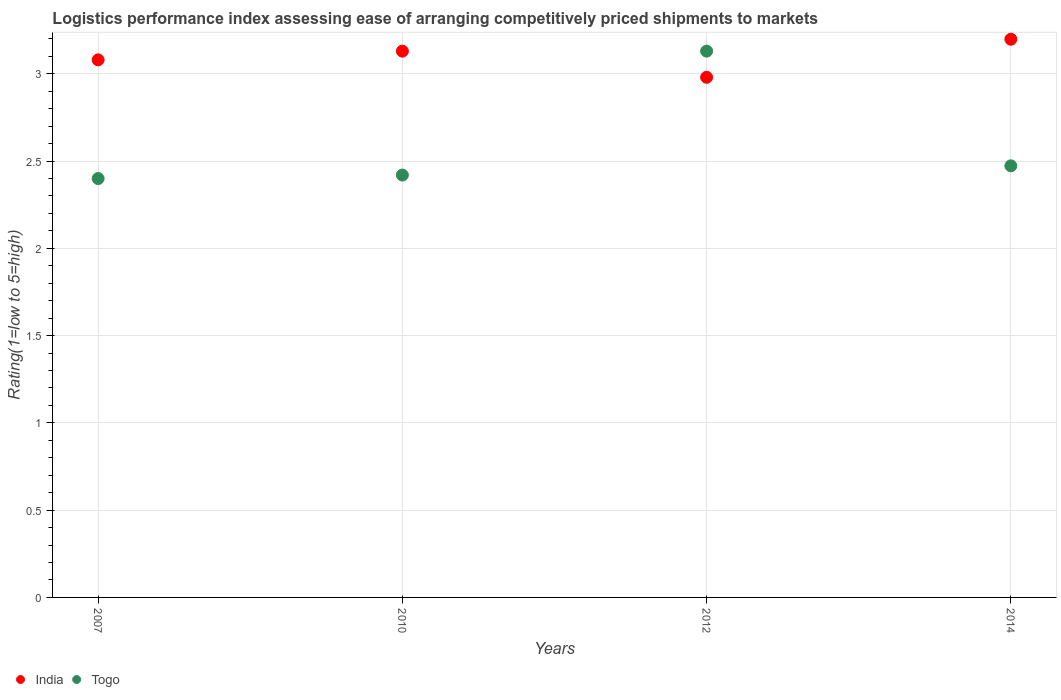Is the number of dotlines equal to the number of legend labels?
Provide a short and direct response. Yes. What is the Logistic performance index in Togo in 2012?
Offer a terse response. 3.13. Across all years, what is the maximum Logistic performance index in Togo?
Make the answer very short. 3.13. What is the total Logistic performance index in India in the graph?
Give a very brief answer. 12.39. What is the difference between the Logistic performance index in India in 2007 and that in 2014?
Your answer should be compact. -0.12. What is the difference between the Logistic performance index in Togo in 2014 and the Logistic performance index in India in 2012?
Keep it short and to the point. -0.51. What is the average Logistic performance index in India per year?
Offer a very short reply. 3.1. In the year 2010, what is the difference between the Logistic performance index in India and Logistic performance index in Togo?
Your response must be concise. 0.71. In how many years, is the Logistic performance index in India greater than 0.5?
Keep it short and to the point. 4. What is the ratio of the Logistic performance index in India in 2012 to that in 2014?
Your answer should be very brief. 0.93. Is the Logistic performance index in India in 2010 less than that in 2014?
Ensure brevity in your answer.  Yes. What is the difference between the highest and the second highest Logistic performance index in India?
Ensure brevity in your answer.  0.07. What is the difference between the highest and the lowest Logistic performance index in Togo?
Offer a terse response. 0.73. In how many years, is the Logistic performance index in Togo greater than the average Logistic performance index in Togo taken over all years?
Give a very brief answer. 1. Is the sum of the Logistic performance index in Togo in 2007 and 2012 greater than the maximum Logistic performance index in India across all years?
Make the answer very short. Yes. Is the Logistic performance index in India strictly greater than the Logistic performance index in Togo over the years?
Your response must be concise. No. Is the Logistic performance index in India strictly less than the Logistic performance index in Togo over the years?
Ensure brevity in your answer.  No. How many dotlines are there?
Give a very brief answer. 2. How many years are there in the graph?
Ensure brevity in your answer.  4. Does the graph contain any zero values?
Offer a very short reply. No. Where does the legend appear in the graph?
Give a very brief answer. Bottom left. How many legend labels are there?
Offer a very short reply. 2. What is the title of the graph?
Your response must be concise. Logistics performance index assessing ease of arranging competitively priced shipments to markets. What is the label or title of the Y-axis?
Ensure brevity in your answer.  Rating(1=low to 5=high). What is the Rating(1=low to 5=high) in India in 2007?
Offer a very short reply. 3.08. What is the Rating(1=low to 5=high) in India in 2010?
Your response must be concise. 3.13. What is the Rating(1=low to 5=high) in Togo in 2010?
Your answer should be compact. 2.42. What is the Rating(1=low to 5=high) of India in 2012?
Your response must be concise. 2.98. What is the Rating(1=low to 5=high) in Togo in 2012?
Ensure brevity in your answer.  3.13. What is the Rating(1=low to 5=high) of India in 2014?
Make the answer very short. 3.2. What is the Rating(1=low to 5=high) of Togo in 2014?
Your response must be concise. 2.47. Across all years, what is the maximum Rating(1=low to 5=high) of India?
Offer a very short reply. 3.2. Across all years, what is the maximum Rating(1=low to 5=high) of Togo?
Provide a succinct answer. 3.13. Across all years, what is the minimum Rating(1=low to 5=high) of India?
Offer a terse response. 2.98. Across all years, what is the minimum Rating(1=low to 5=high) of Togo?
Provide a short and direct response. 2.4. What is the total Rating(1=low to 5=high) of India in the graph?
Your response must be concise. 12.39. What is the total Rating(1=low to 5=high) of Togo in the graph?
Your response must be concise. 10.42. What is the difference between the Rating(1=low to 5=high) in India in 2007 and that in 2010?
Your response must be concise. -0.05. What is the difference between the Rating(1=low to 5=high) in Togo in 2007 and that in 2010?
Your response must be concise. -0.02. What is the difference between the Rating(1=low to 5=high) of Togo in 2007 and that in 2012?
Provide a succinct answer. -0.73. What is the difference between the Rating(1=low to 5=high) of India in 2007 and that in 2014?
Keep it short and to the point. -0.12. What is the difference between the Rating(1=low to 5=high) in Togo in 2007 and that in 2014?
Provide a short and direct response. -0.07. What is the difference between the Rating(1=low to 5=high) of India in 2010 and that in 2012?
Keep it short and to the point. 0.15. What is the difference between the Rating(1=low to 5=high) of Togo in 2010 and that in 2012?
Your answer should be compact. -0.71. What is the difference between the Rating(1=low to 5=high) of India in 2010 and that in 2014?
Provide a succinct answer. -0.07. What is the difference between the Rating(1=low to 5=high) in Togo in 2010 and that in 2014?
Offer a very short reply. -0.05. What is the difference between the Rating(1=low to 5=high) in India in 2012 and that in 2014?
Provide a short and direct response. -0.22. What is the difference between the Rating(1=low to 5=high) of Togo in 2012 and that in 2014?
Provide a succinct answer. 0.66. What is the difference between the Rating(1=low to 5=high) in India in 2007 and the Rating(1=low to 5=high) in Togo in 2010?
Ensure brevity in your answer.  0.66. What is the difference between the Rating(1=low to 5=high) of India in 2007 and the Rating(1=low to 5=high) of Togo in 2014?
Provide a succinct answer. 0.61. What is the difference between the Rating(1=low to 5=high) in India in 2010 and the Rating(1=low to 5=high) in Togo in 2014?
Provide a succinct answer. 0.66. What is the difference between the Rating(1=low to 5=high) in India in 2012 and the Rating(1=low to 5=high) in Togo in 2014?
Your answer should be very brief. 0.51. What is the average Rating(1=low to 5=high) of India per year?
Offer a terse response. 3.1. What is the average Rating(1=low to 5=high) in Togo per year?
Offer a terse response. 2.61. In the year 2007, what is the difference between the Rating(1=low to 5=high) of India and Rating(1=low to 5=high) of Togo?
Your answer should be very brief. 0.68. In the year 2010, what is the difference between the Rating(1=low to 5=high) of India and Rating(1=low to 5=high) of Togo?
Provide a short and direct response. 0.71. In the year 2012, what is the difference between the Rating(1=low to 5=high) in India and Rating(1=low to 5=high) in Togo?
Your answer should be compact. -0.15. In the year 2014, what is the difference between the Rating(1=low to 5=high) in India and Rating(1=low to 5=high) in Togo?
Give a very brief answer. 0.73. What is the ratio of the Rating(1=low to 5=high) in Togo in 2007 to that in 2010?
Your response must be concise. 0.99. What is the ratio of the Rating(1=low to 5=high) of India in 2007 to that in 2012?
Ensure brevity in your answer.  1.03. What is the ratio of the Rating(1=low to 5=high) in Togo in 2007 to that in 2012?
Give a very brief answer. 0.77. What is the ratio of the Rating(1=low to 5=high) of India in 2007 to that in 2014?
Offer a terse response. 0.96. What is the ratio of the Rating(1=low to 5=high) of Togo in 2007 to that in 2014?
Offer a terse response. 0.97. What is the ratio of the Rating(1=low to 5=high) of India in 2010 to that in 2012?
Give a very brief answer. 1.05. What is the ratio of the Rating(1=low to 5=high) of Togo in 2010 to that in 2012?
Ensure brevity in your answer.  0.77. What is the ratio of the Rating(1=low to 5=high) in India in 2010 to that in 2014?
Give a very brief answer. 0.98. What is the ratio of the Rating(1=low to 5=high) in Togo in 2010 to that in 2014?
Keep it short and to the point. 0.98. What is the ratio of the Rating(1=low to 5=high) in India in 2012 to that in 2014?
Your answer should be compact. 0.93. What is the ratio of the Rating(1=low to 5=high) of Togo in 2012 to that in 2014?
Provide a short and direct response. 1.27. What is the difference between the highest and the second highest Rating(1=low to 5=high) in India?
Give a very brief answer. 0.07. What is the difference between the highest and the second highest Rating(1=low to 5=high) of Togo?
Offer a very short reply. 0.66. What is the difference between the highest and the lowest Rating(1=low to 5=high) in India?
Your response must be concise. 0.22. What is the difference between the highest and the lowest Rating(1=low to 5=high) in Togo?
Your response must be concise. 0.73. 